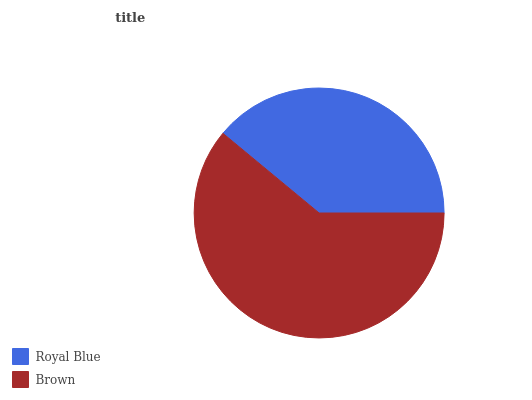Is Royal Blue the minimum?
Answer yes or no. Yes. Is Brown the maximum?
Answer yes or no. Yes. Is Brown the minimum?
Answer yes or no. No. Is Brown greater than Royal Blue?
Answer yes or no. Yes. Is Royal Blue less than Brown?
Answer yes or no. Yes. Is Royal Blue greater than Brown?
Answer yes or no. No. Is Brown less than Royal Blue?
Answer yes or no. No. Is Brown the high median?
Answer yes or no. Yes. Is Royal Blue the low median?
Answer yes or no. Yes. Is Royal Blue the high median?
Answer yes or no. No. Is Brown the low median?
Answer yes or no. No. 